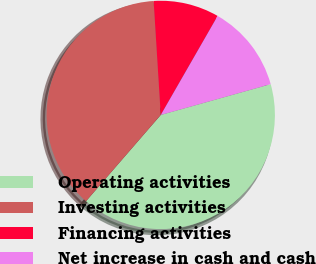<chart> <loc_0><loc_0><loc_500><loc_500><pie_chart><fcel>Operating activities<fcel>Investing activities<fcel>Financing activities<fcel>Net increase in cash and cash<nl><fcel>40.71%<fcel>37.65%<fcel>9.29%<fcel>12.35%<nl></chart> 